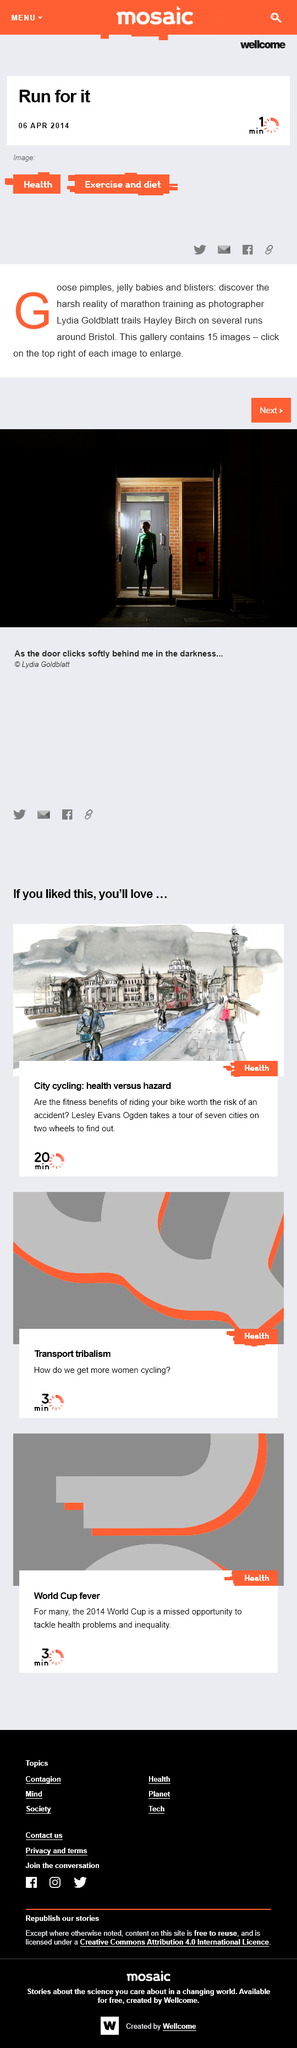Point out several critical features in this image. In 2014, the article was determined to be sharable on Facebook. Lydia Goldblatt is not a marathon runner but rather a photographer. There are 15 photographs of Hayley Birch included in this article. 